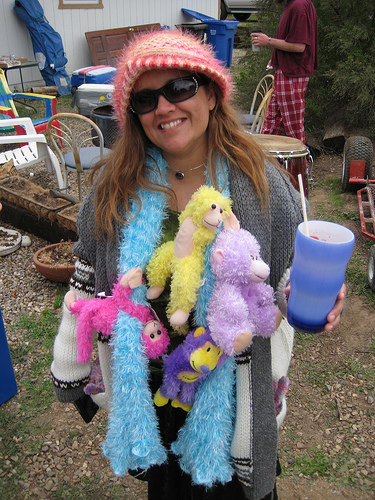<image>
Is the monkey on the woman? Yes. Looking at the image, I can see the monkey is positioned on top of the woman, with the woman providing support. Is the trash can behind the drum? Yes. From this viewpoint, the trash can is positioned behind the drum, with the drum partially or fully occluding the trash can. Is the woman in front of the drum? Yes. The woman is positioned in front of the drum, appearing closer to the camera viewpoint. 